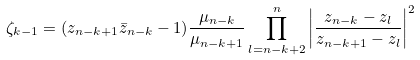<formula> <loc_0><loc_0><loc_500><loc_500>\zeta _ { k - 1 } = ( z _ { n - k + 1 } \bar { z } _ { n - k } - 1 ) \frac { \mu _ { n - k } } { \mu _ { n - k + 1 } } \prod _ { l = n - k + 2 } ^ { n } \left | \frac { z _ { n - k } - z _ { l } } { z _ { n - k + 1 } - z _ { l } } \right | ^ { 2 }</formula> 